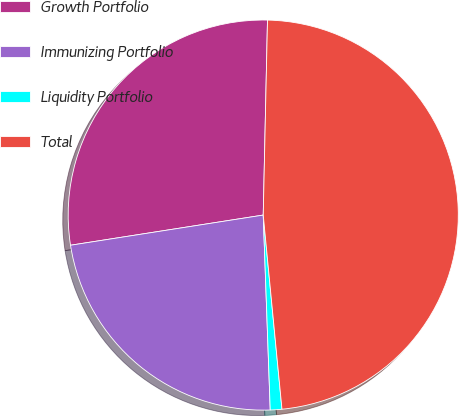<chart> <loc_0><loc_0><loc_500><loc_500><pie_chart><fcel>Growth Portfolio<fcel>Immunizing Portfolio<fcel>Liquidity Portfolio<fcel>Total<nl><fcel>27.82%<fcel>23.1%<fcel>0.96%<fcel>48.12%<nl></chart> 